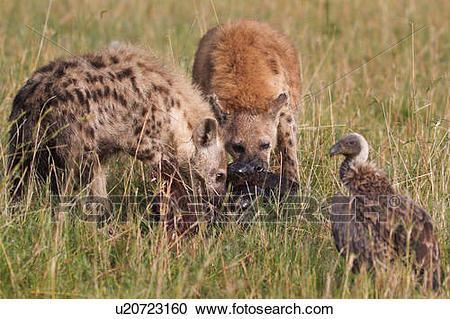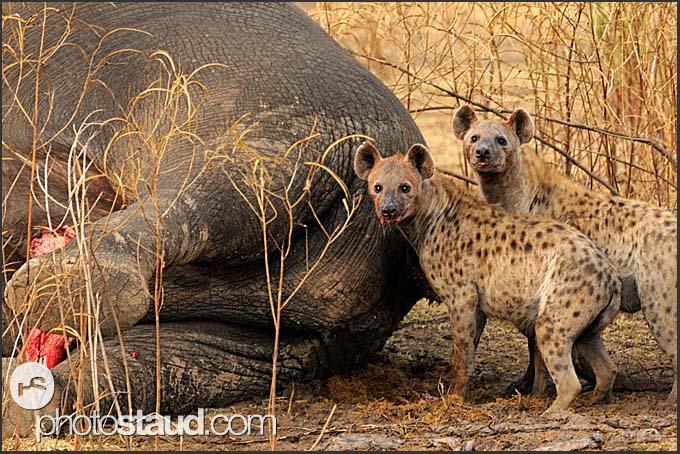The first image is the image on the left, the second image is the image on the right. Given the left and right images, does the statement "A hyena is carrying off the head of its prey in one of the images." hold true? Answer yes or no. No. The first image is the image on the left, the second image is the image on the right. Evaluate the accuracy of this statement regarding the images: "At least one animal is carrying a piece of its prey in its mouth.". Is it true? Answer yes or no. No. 